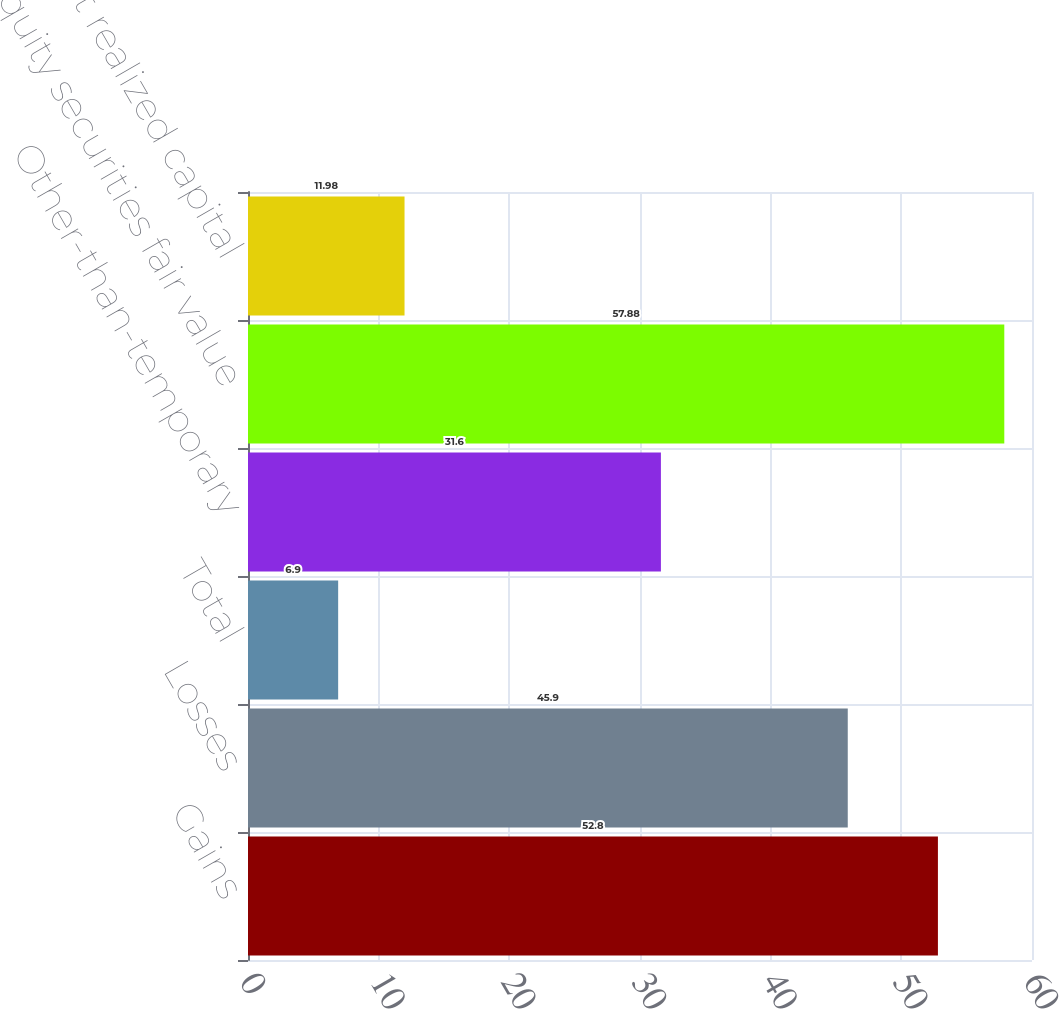<chart> <loc_0><loc_0><loc_500><loc_500><bar_chart><fcel>Gains<fcel>Losses<fcel>Total<fcel>Other-than-temporary<fcel>Equity securities fair value<fcel>Total net realized capital<nl><fcel>52.8<fcel>45.9<fcel>6.9<fcel>31.6<fcel>57.88<fcel>11.98<nl></chart> 